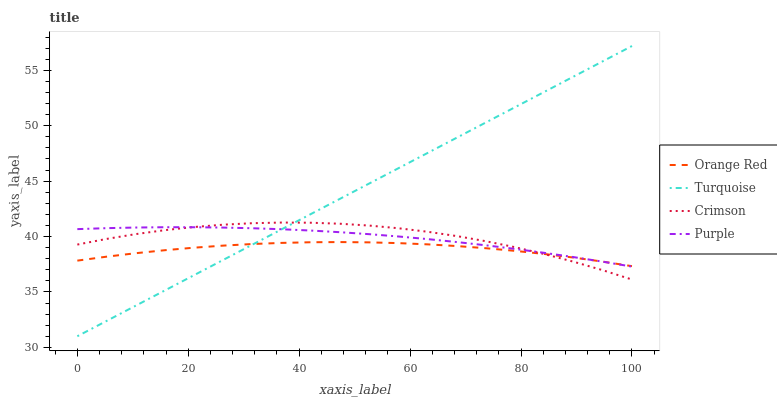Does Orange Red have the minimum area under the curve?
Answer yes or no. Yes. Does Turquoise have the maximum area under the curve?
Answer yes or no. Yes. Does Purple have the minimum area under the curve?
Answer yes or no. No. Does Purple have the maximum area under the curve?
Answer yes or no. No. Is Turquoise the smoothest?
Answer yes or no. Yes. Is Crimson the roughest?
Answer yes or no. Yes. Is Purple the smoothest?
Answer yes or no. No. Is Purple the roughest?
Answer yes or no. No. Does Purple have the lowest value?
Answer yes or no. No. Does Turquoise have the highest value?
Answer yes or no. Yes. Does Purple have the highest value?
Answer yes or no. No. Does Crimson intersect Orange Red?
Answer yes or no. Yes. Is Crimson less than Orange Red?
Answer yes or no. No. Is Crimson greater than Orange Red?
Answer yes or no. No. 